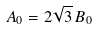Convert formula to latex. <formula><loc_0><loc_0><loc_500><loc_500>A _ { 0 } = 2 \sqrt { 3 } \, B _ { 0 }</formula> 